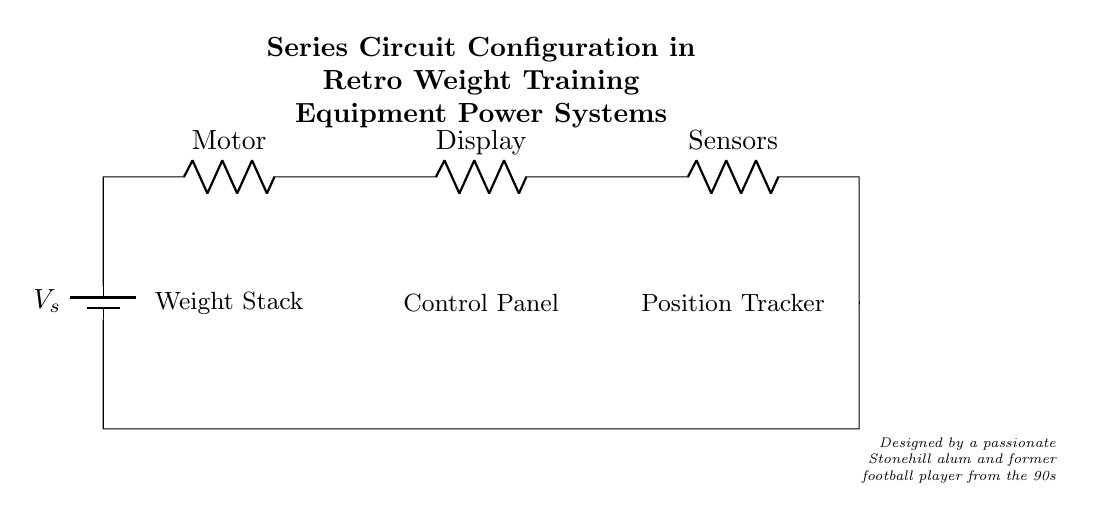What is the main power source in the circuit? The main power source is the battery, indicated by the symbol. It provides voltage necessary for the circuit to operate.
Answer: battery How many resistors are in the circuit? There are three resistors labeled as Motor, Display, and Sensors. Each component represents a resistor that the current flows through in series.
Answer: three What component is connected directly to the battery? The component connected directly to the battery is the Motor, which is the first resistor in the series connection.
Answer: Motor What does the weight stack represent in this circuit? The weight stack is part of the overall system, representing a load that the circuit is designed to power. This is indicated by the placement and label in the diagram.
Answer: load If the voltage across the battery is 12 volts, what is the voltage across each resistor assuming equal resistance? Since the resistors are in series, the voltage would be divided equally among them. Therefore, each resistor would have a voltage drop of 4 volts with a total of 12 volts across all three.
Answer: 4 volts What type of circuit configuration does this diagram illustrate? The circuit configuration illustrated is a series circuit, where components are connected end-to-end, allowing current flow through each one sequentially.
Answer: series circuit Where is the control panel located in the circuit? The control panel is located between the Display and the Position Tracker in the series arrangement of components, indicating its position in the power system.
Answer: between Display and Position Tracker 